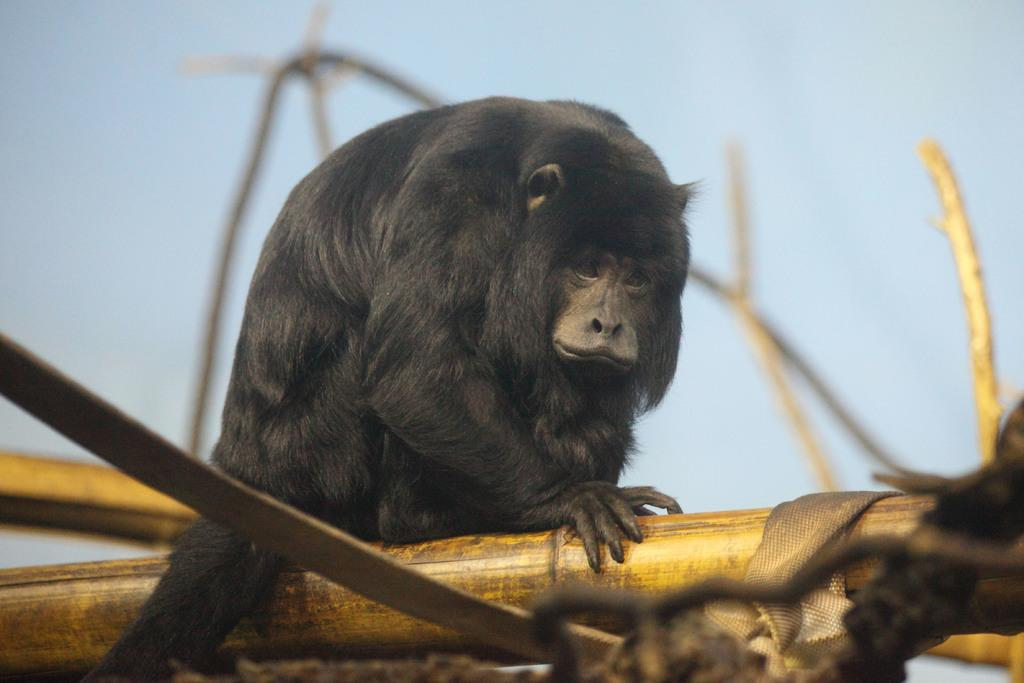What type of creature is in the image? There is an animal in the image. What is the animal standing on? The animal is on a wooden surface. What can be seen in the background of the image? The sky is visible in the background of the image. What advice does the animal's uncle give in the image? There is no uncle present in the image, nor is there any conversation or advice being given. 